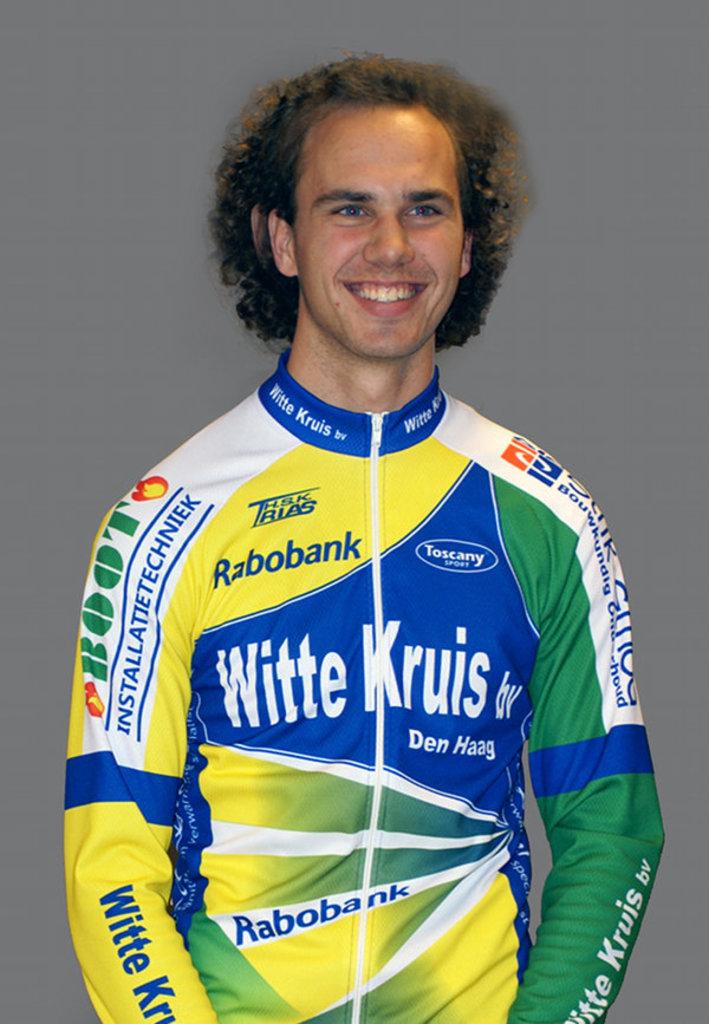What bank is one of his sponsors?
Your answer should be compact. Rabobank. What does it say on the blue part of the man's jersey?
Ensure brevity in your answer.  Witte kruis. 